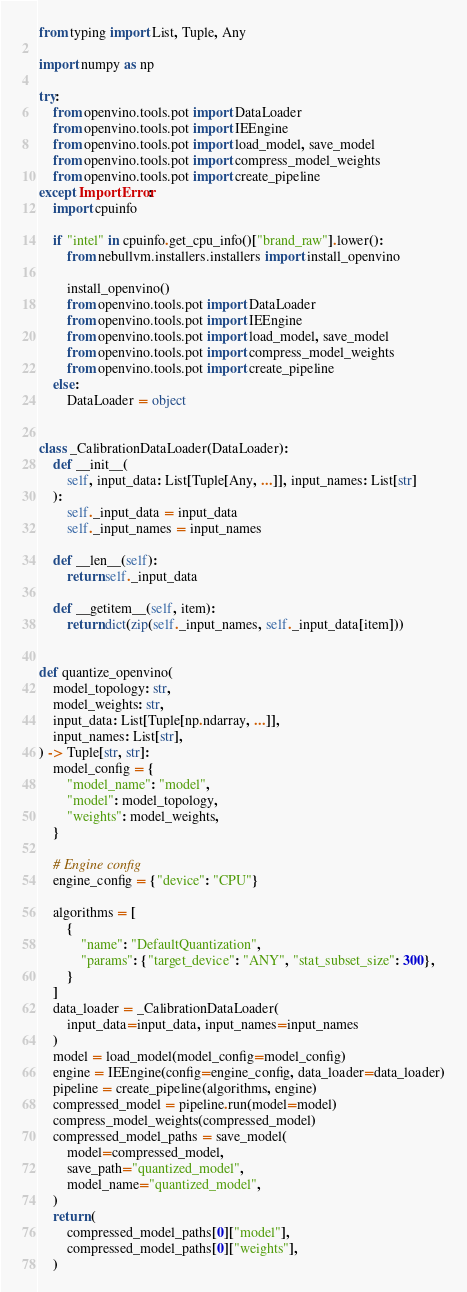<code> <loc_0><loc_0><loc_500><loc_500><_Python_>from typing import List, Tuple, Any

import numpy as np

try:
    from openvino.tools.pot import DataLoader
    from openvino.tools.pot import IEEngine
    from openvino.tools.pot import load_model, save_model
    from openvino.tools.pot import compress_model_weights
    from openvino.tools.pot import create_pipeline
except ImportError:
    import cpuinfo

    if "intel" in cpuinfo.get_cpu_info()["brand_raw"].lower():
        from nebullvm.installers.installers import install_openvino

        install_openvino()
        from openvino.tools.pot import DataLoader
        from openvino.tools.pot import IEEngine
        from openvino.tools.pot import load_model, save_model
        from openvino.tools.pot import compress_model_weights
        from openvino.tools.pot import create_pipeline
    else:
        DataLoader = object


class _CalibrationDataLoader(DataLoader):
    def __init__(
        self, input_data: List[Tuple[Any, ...]], input_names: List[str]
    ):
        self._input_data = input_data
        self._input_names = input_names

    def __len__(self):
        return self._input_data

    def __getitem__(self, item):
        return dict(zip(self._input_names, self._input_data[item]))


def quantize_openvino(
    model_topology: str,
    model_weights: str,
    input_data: List[Tuple[np.ndarray, ...]],
    input_names: List[str],
) -> Tuple[str, str]:
    model_config = {
        "model_name": "model",
        "model": model_topology,
        "weights": model_weights,
    }

    # Engine config
    engine_config = {"device": "CPU"}

    algorithms = [
        {
            "name": "DefaultQuantization",
            "params": {"target_device": "ANY", "stat_subset_size": 300},
        }
    ]
    data_loader = _CalibrationDataLoader(
        input_data=input_data, input_names=input_names
    )
    model = load_model(model_config=model_config)
    engine = IEEngine(config=engine_config, data_loader=data_loader)
    pipeline = create_pipeline(algorithms, engine)
    compressed_model = pipeline.run(model=model)
    compress_model_weights(compressed_model)
    compressed_model_paths = save_model(
        model=compressed_model,
        save_path="quantized_model",
        model_name="quantized_model",
    )
    return (
        compressed_model_paths[0]["model"],
        compressed_model_paths[0]["weights"],
    )
</code> 